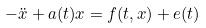<formula> <loc_0><loc_0><loc_500><loc_500>- \ddot { x } + a ( t ) x = f ( t , x ) + e ( t )</formula> 